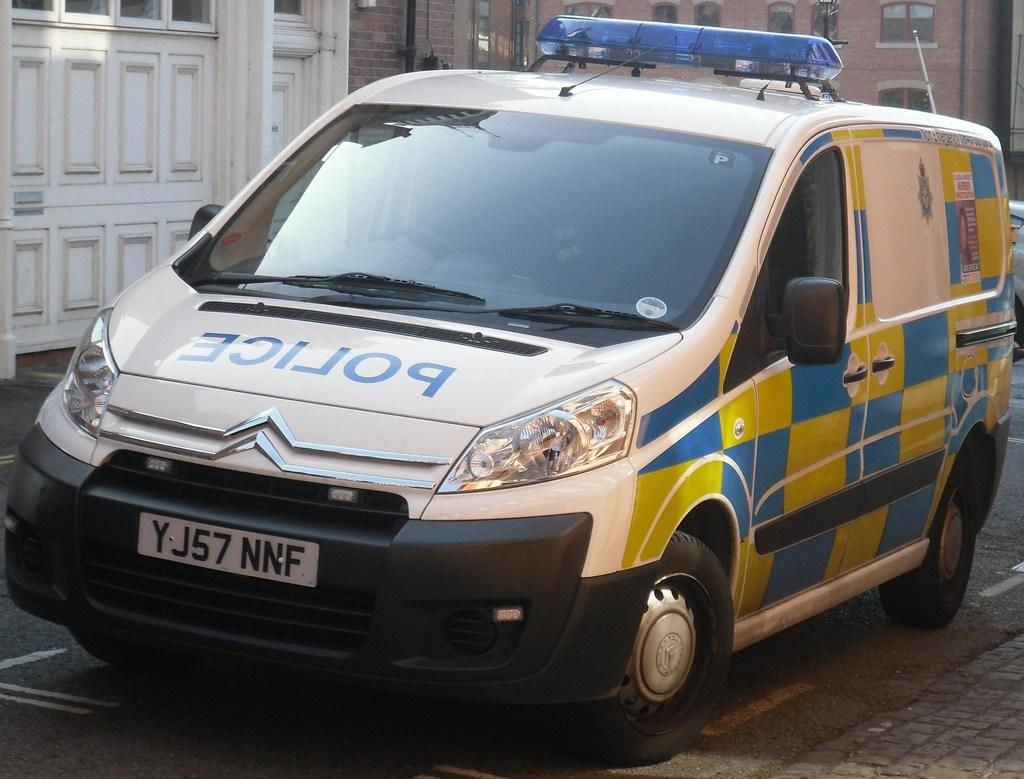What is the main subject of the image? There is a vehicle in the image. What can be seen on the vehicle? The vehicle has a number plate and text associated with it. What else is present in the image besides the vehicle? There is a building in the image. What features can be observed on the building? The building has windows. What type of company is protesting in the image? There is no protest or company present in the image; it features a vehicle and a building. What kind of whip is being used by the driver in the image? There is no whip or driver present in the image; it only shows a vehicle and a building. 